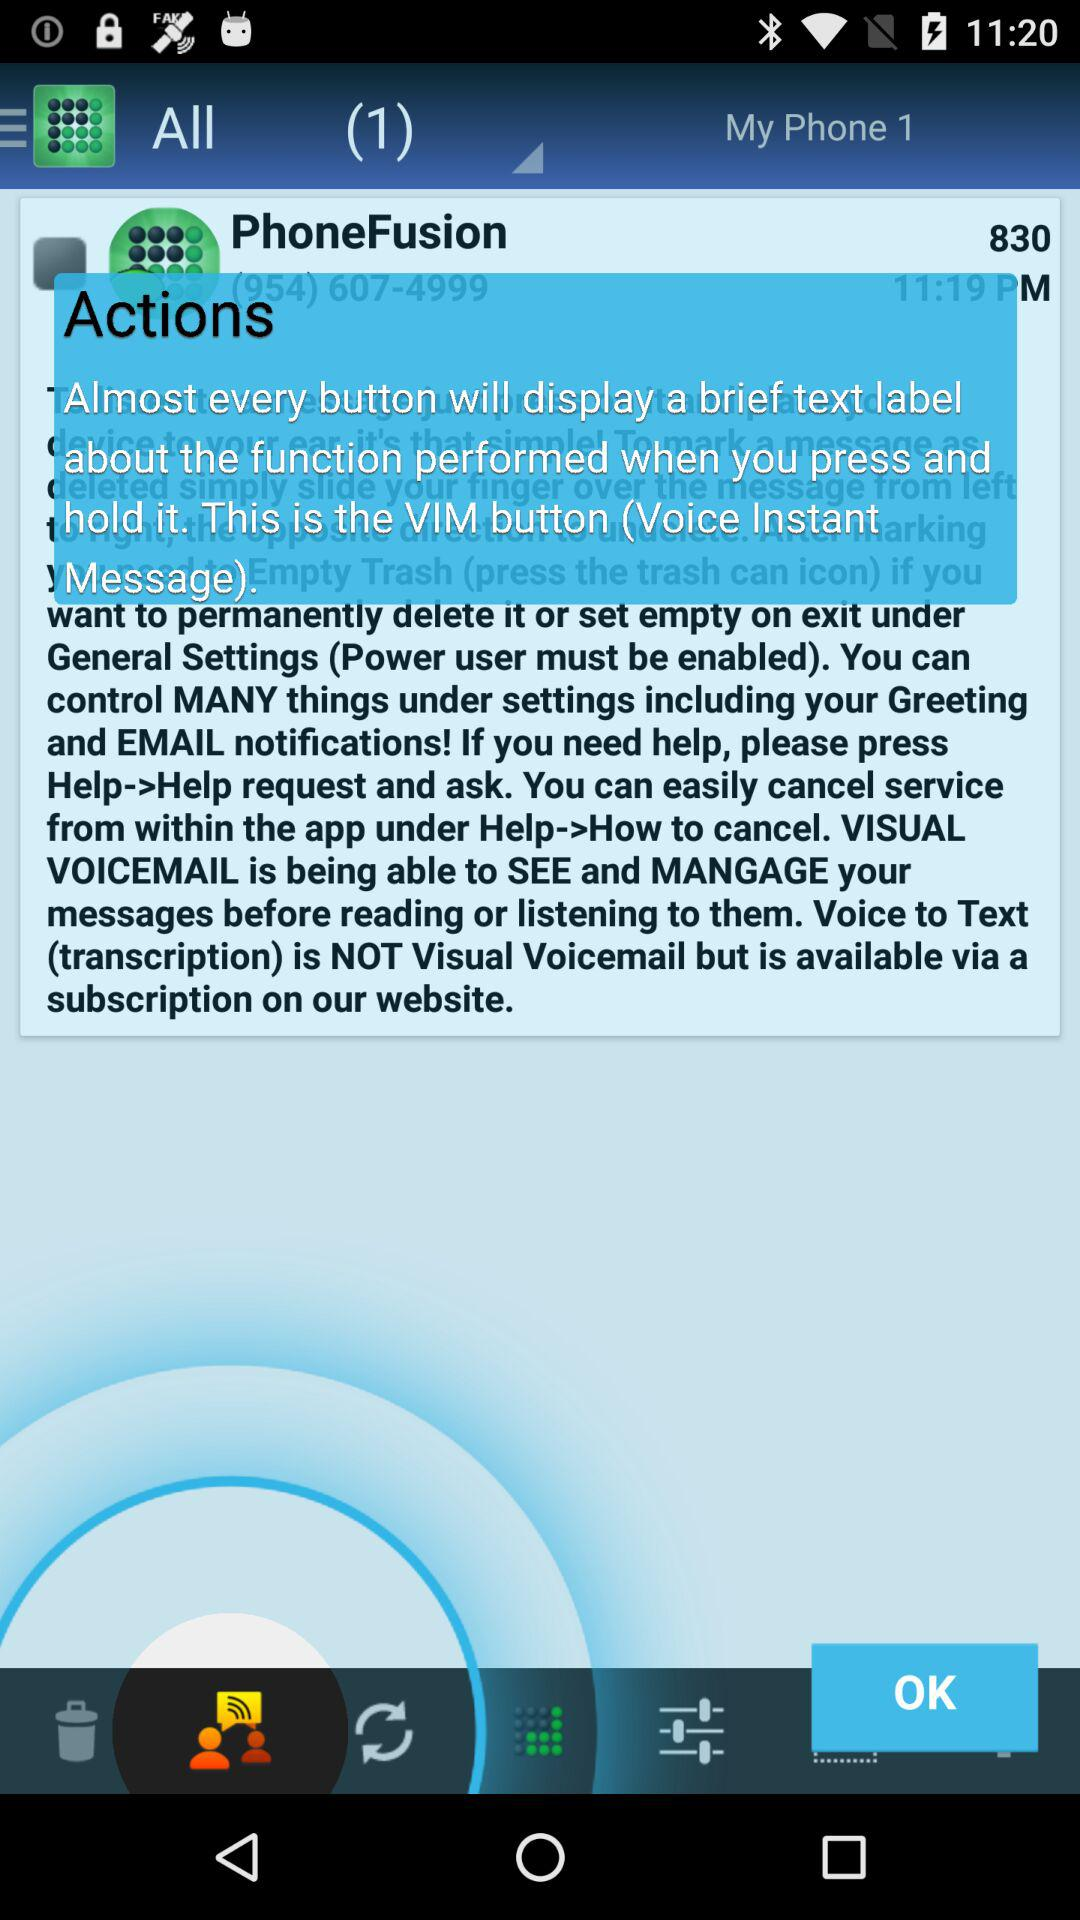What is the "PhoneFusion" phone number? The "PhoneFusion" phone number is (954) 607-4999. 